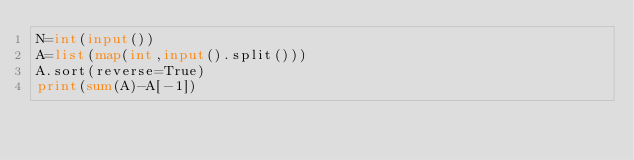Convert code to text. <code><loc_0><loc_0><loc_500><loc_500><_Python_>N=int(input())
A=list(map(int,input().split()))
A.sort(reverse=True)
print(sum(A)-A[-1])</code> 